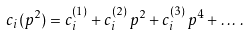<formula> <loc_0><loc_0><loc_500><loc_500>c _ { i } ( p ^ { 2 } ) = c _ { i } ^ { ( 1 ) } + c _ { i } ^ { ( 2 ) } \, p ^ { 2 } + c _ { i } ^ { ( 3 ) } \, p ^ { 4 } + \dots \, .</formula> 